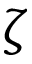<formula> <loc_0><loc_0><loc_500><loc_500>\zeta</formula> 